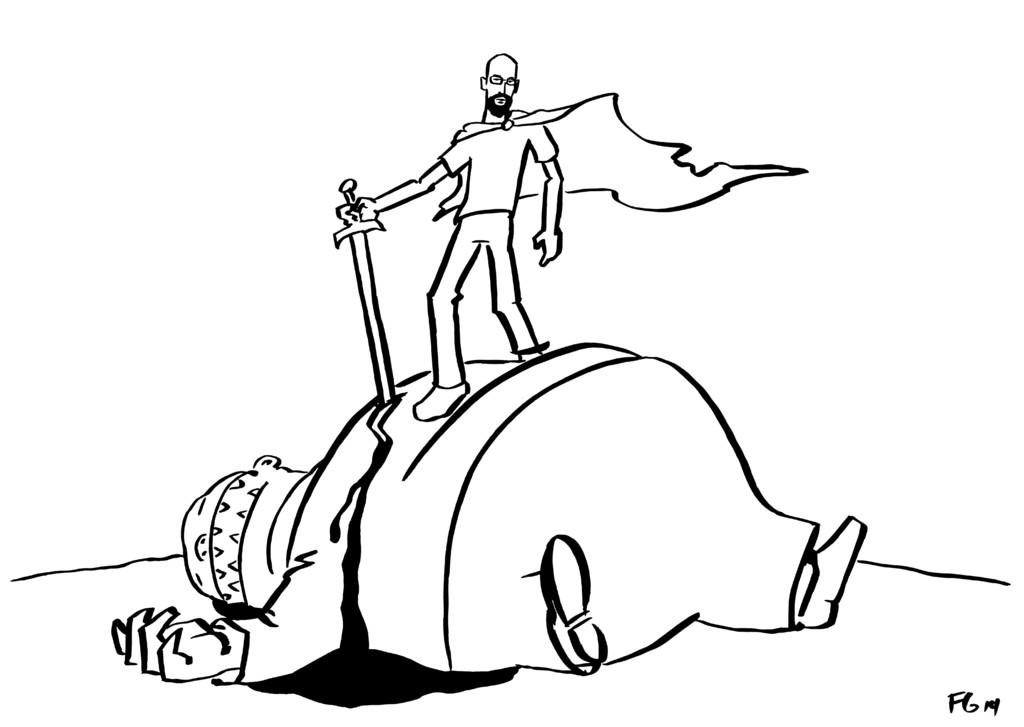What is the position of the man in the image? There is a man laying in the image. Is there another man in the image? Yes, there is a man standing on top of the laying man in the image. What type of ice can be seen in the nest in the image? There is no ice or nest present in the image; it features two men, one laying down and the other standing on top of him. 